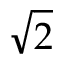Convert formula to latex. <formula><loc_0><loc_0><loc_500><loc_500>\sqrt { 2 }</formula> 